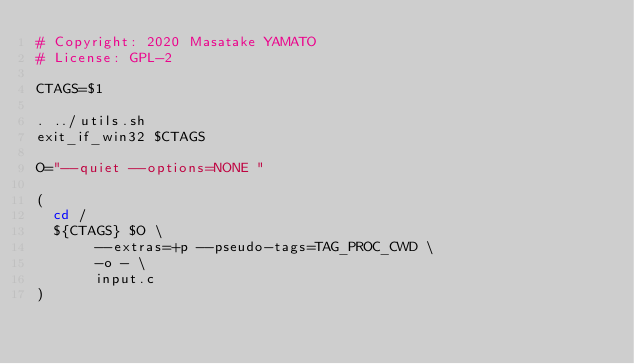<code> <loc_0><loc_0><loc_500><loc_500><_Bash_># Copyright: 2020 Masatake YAMATO
# License: GPL-2

CTAGS=$1

. ../utils.sh
exit_if_win32 $CTAGS

O="--quiet --options=NONE "

(
	cd /
	${CTAGS} $O \
			 --extras=+p --pseudo-tags=TAG_PROC_CWD \
			 -o - \
			 input.c
)
</code> 